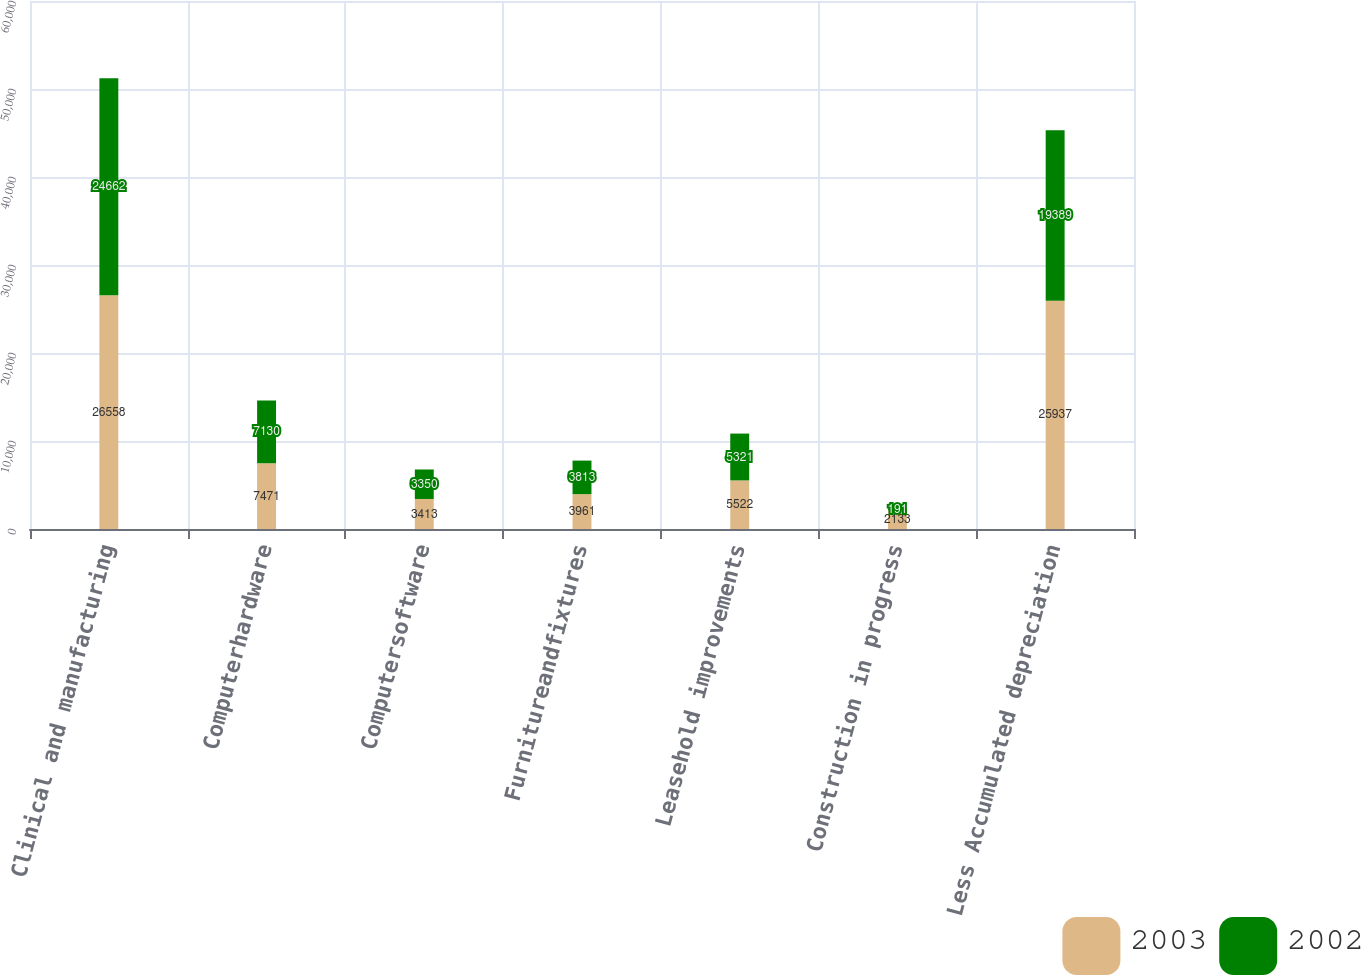Convert chart. <chart><loc_0><loc_0><loc_500><loc_500><stacked_bar_chart><ecel><fcel>Clinical and manufacturing<fcel>Computerhardware<fcel>Computersoftware<fcel>Furnitureandfixtures<fcel>Leasehold improvements<fcel>Construction in progress<fcel>Less Accumulated depreciation<nl><fcel>2003<fcel>26558<fcel>7471<fcel>3413<fcel>3961<fcel>5522<fcel>2133<fcel>25937<nl><fcel>2002<fcel>24662<fcel>7130<fcel>3350<fcel>3813<fcel>5321<fcel>191<fcel>19389<nl></chart> 